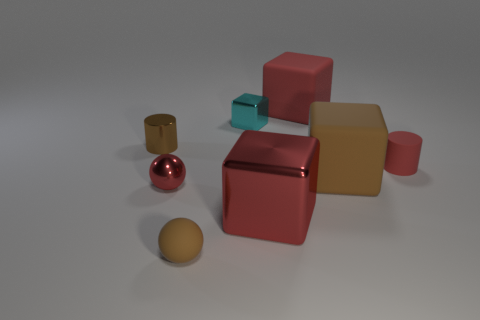The other cube that is the same material as the large brown block is what size?
Your answer should be compact. Large. There is a brown object that is in front of the brown metallic thing and behind the small brown sphere; what is it made of?
Your answer should be very brief. Rubber. How many matte objects have the same size as the red metal ball?
Your response must be concise. 2. What material is the big brown thing that is the same shape as the tiny cyan shiny object?
Keep it short and to the point. Rubber. What number of things are either brown things that are on the left side of the red shiny block or cubes behind the brown metal cylinder?
Your answer should be compact. 4. There is a brown metallic thing; is its shape the same as the red object to the left of the tiny rubber sphere?
Provide a succinct answer. No. There is a small thing that is on the left side of the small sphere that is behind the tiny sphere in front of the small red metal thing; what is its shape?
Offer a very short reply. Cylinder. What number of other objects are the same material as the tiny red cylinder?
Make the answer very short. 3. How many objects are small objects behind the big red metallic thing or small yellow shiny objects?
Provide a short and direct response. 4. What is the shape of the tiny matte object that is right of the tiny cyan cube that is left of the large metal object?
Your answer should be compact. Cylinder. 